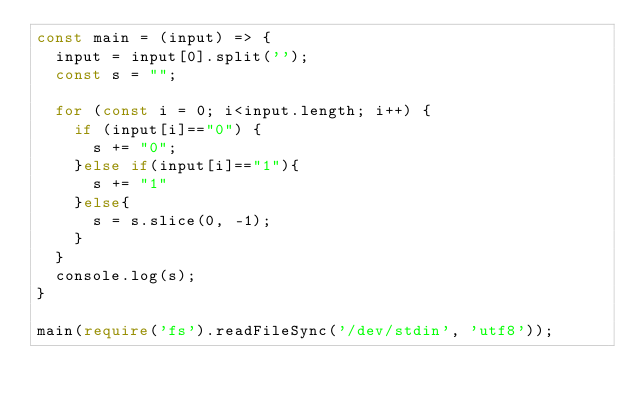<code> <loc_0><loc_0><loc_500><loc_500><_TypeScript_>const main = (input) => {
  input = input[0].split('');
  const s = "";
  
  for (const i = 0; i<input.length; i++) {
    if (input[i]=="0") {
      s += "0";
    }else if(input[i]=="1"){
      s += "1"
    }else{
      s = s.slice(0, -1);
    }
  }
  console.log(s);
}
 
main(require('fs').readFileSync('/dev/stdin', 'utf8'));</code> 